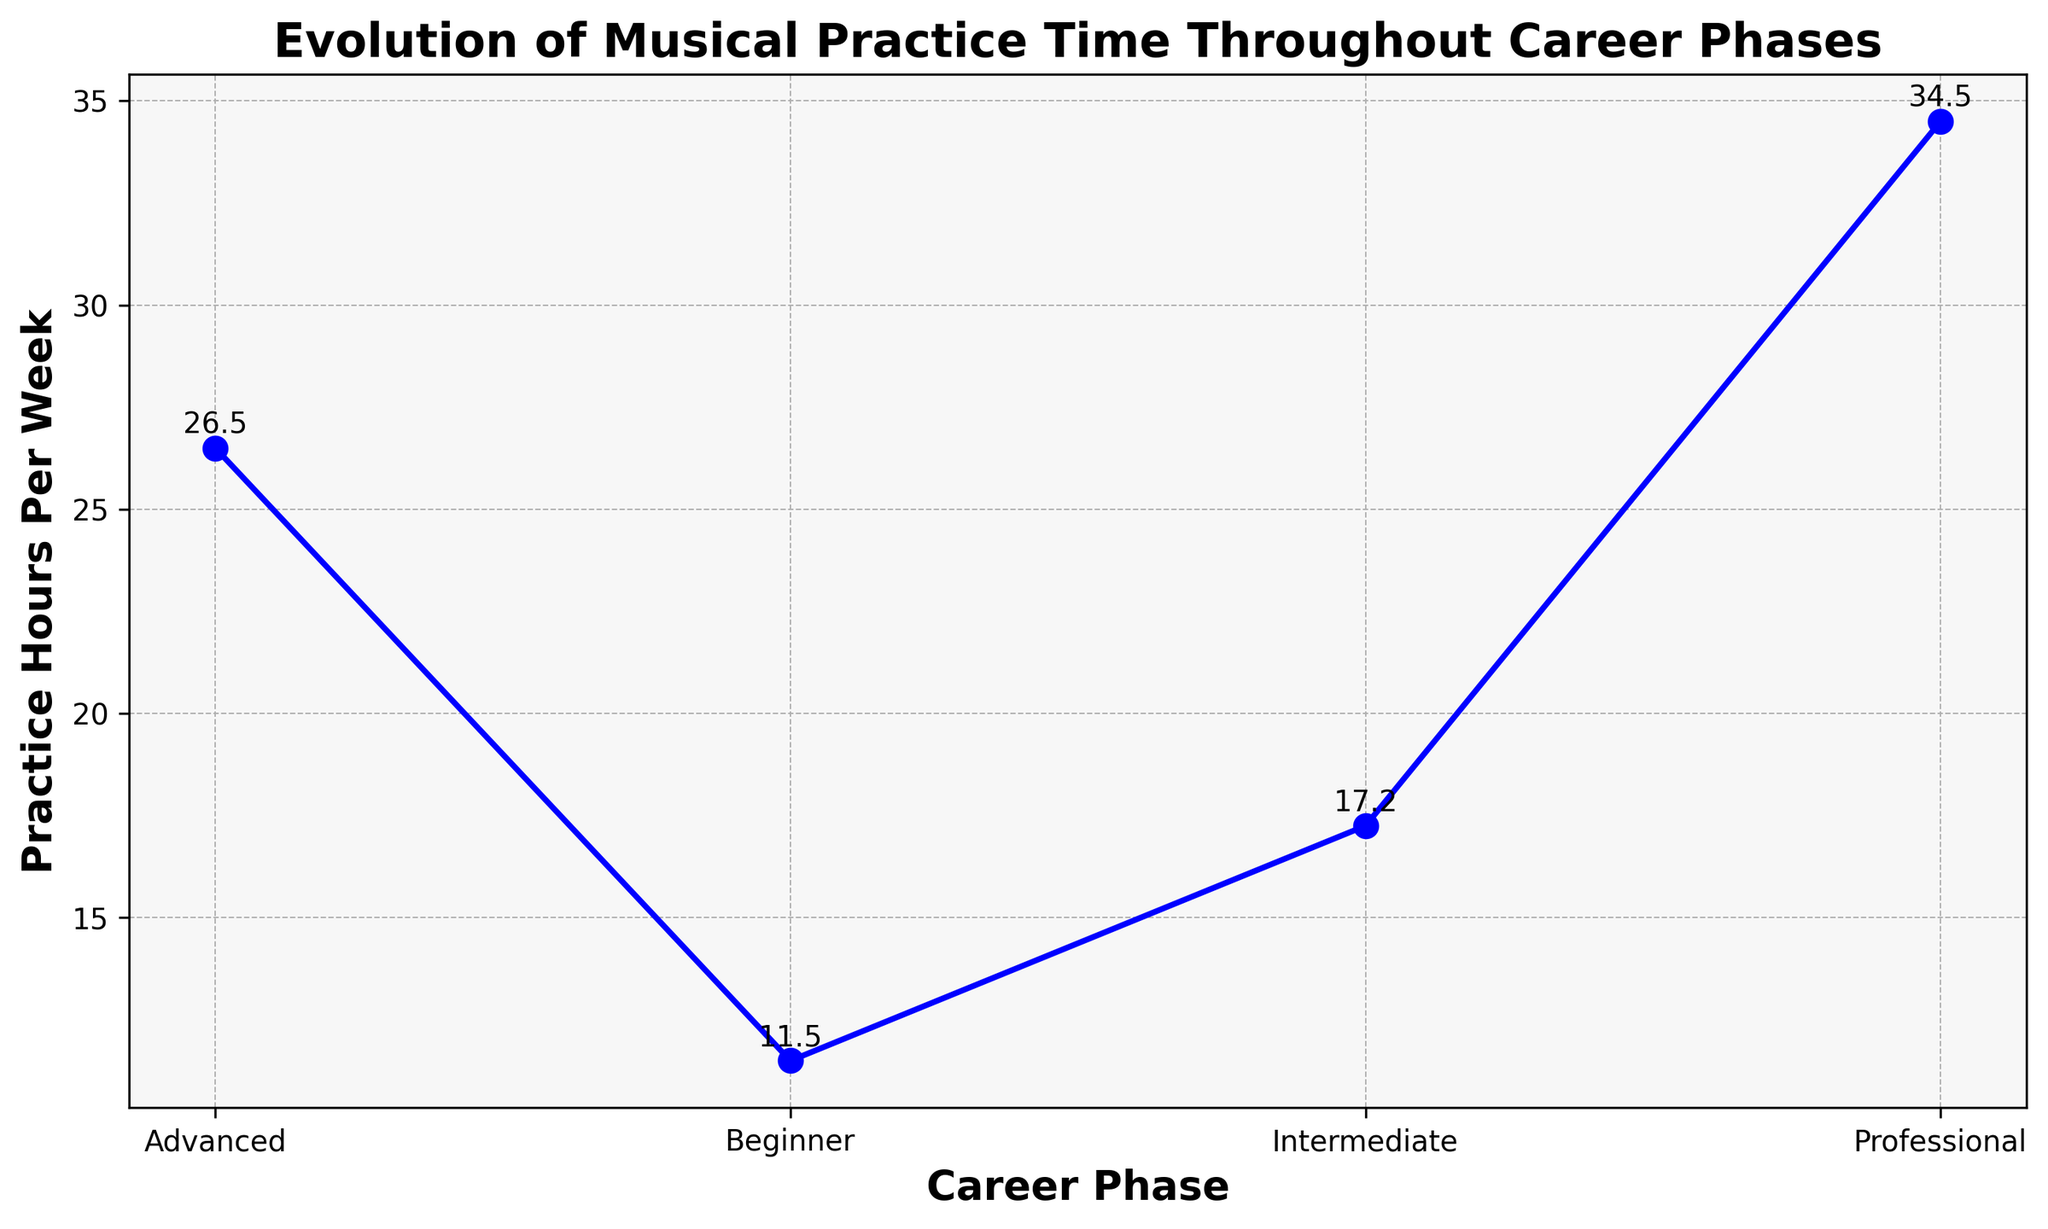What's the average practice hours per week for the Beginner phase? We average the practice hours listed for the Beginner phase: (10 + 12 + 11 + 13) / 4 = 11.5
Answer: 11.5 Which career phase shows the highest average practice hours per week? The highest point on the y-axis, which represents the practice hours per week, occurs in the Professional phase.
Answer: Professional How does the average practice hours per week of the Intermediate phase compare to the Advanced phase? By comparing the averages on the y-axis: Intermediate phase (~17.3) is less than Advanced phase (~26.5).
Answer: Intermediate is less than Advanced What is the increase in average practice hours per week from the Beginner to Intermediate phase? Subtract the average practice hours for Beginner (11.5) from Intermediate (17.3): 17.3 - 11.5 = 5.8
Answer: 5.8 What is the range of average practice hours per week in the Professional phase? The average practice hours for the Professional phase ranges around 34.5, comparing the highest (36) and lowest point (33) from the data.
Answer: 33 to 36 Which two consecutive career phases show the largest increase in average practice hours per week? Calculate the difference between the averages of consecutive phases: (Intermediate to Beginner) 17.3 - 11.5 = 5.8, (Advanced to Intermediate) 26.5 - 17.3 = 9.2, (Professional to Advanced) 34.5 - 26.5 = 8. The largest increase is from Intermediate to Advanced.
Answer: Intermediate to Advanced Is the average practice hours per week higher in the Beginner phase or the Intermediate phase? Compare the averages: Beginner (11.5) vs Intermediate (17.3). Intermediate is higher.
Answer: Intermediate How much more practice hours per week do Professional musicians have compared to Advanced musicians on average? Subtract Advanced (26.5) from Professional (34.5): 34.5 - 26.5 = 8
Answer: 8 What's the total average practice hours per week for all phases combined? Sum all average values: Beginner (11.5) + Intermediate (17.3) + Advanced (26.5) + Professional (34.5) = 89.8
Answer: 89.8 